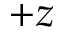Convert formula to latex. <formula><loc_0><loc_0><loc_500><loc_500>+ z</formula> 